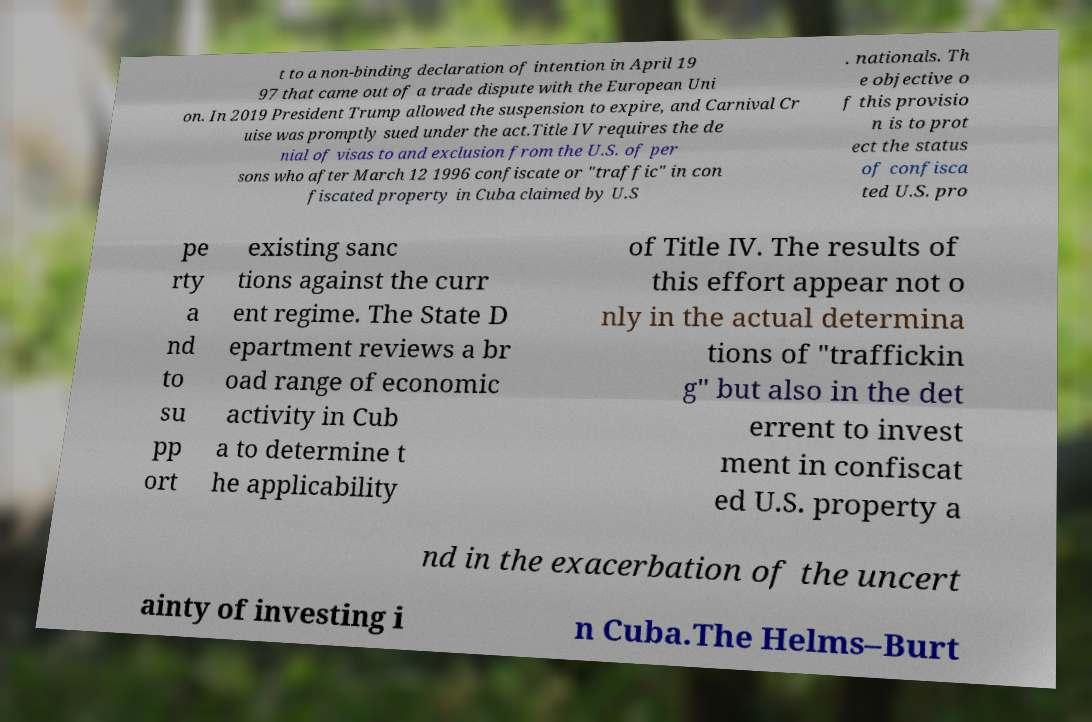There's text embedded in this image that I need extracted. Can you transcribe it verbatim? t to a non-binding declaration of intention in April 19 97 that came out of a trade dispute with the European Uni on. In 2019 President Trump allowed the suspension to expire, and Carnival Cr uise was promptly sued under the act.Title IV requires the de nial of visas to and exclusion from the U.S. of per sons who after March 12 1996 confiscate or "traffic" in con fiscated property in Cuba claimed by U.S . nationals. Th e objective o f this provisio n is to prot ect the status of confisca ted U.S. pro pe rty a nd to su pp ort existing sanc tions against the curr ent regime. The State D epartment reviews a br oad range of economic activity in Cub a to determine t he applicability of Title IV. The results of this effort appear not o nly in the actual determina tions of "traffickin g" but also in the det errent to invest ment in confiscat ed U.S. property a nd in the exacerbation of the uncert ainty of investing i n Cuba.The Helms–Burt 